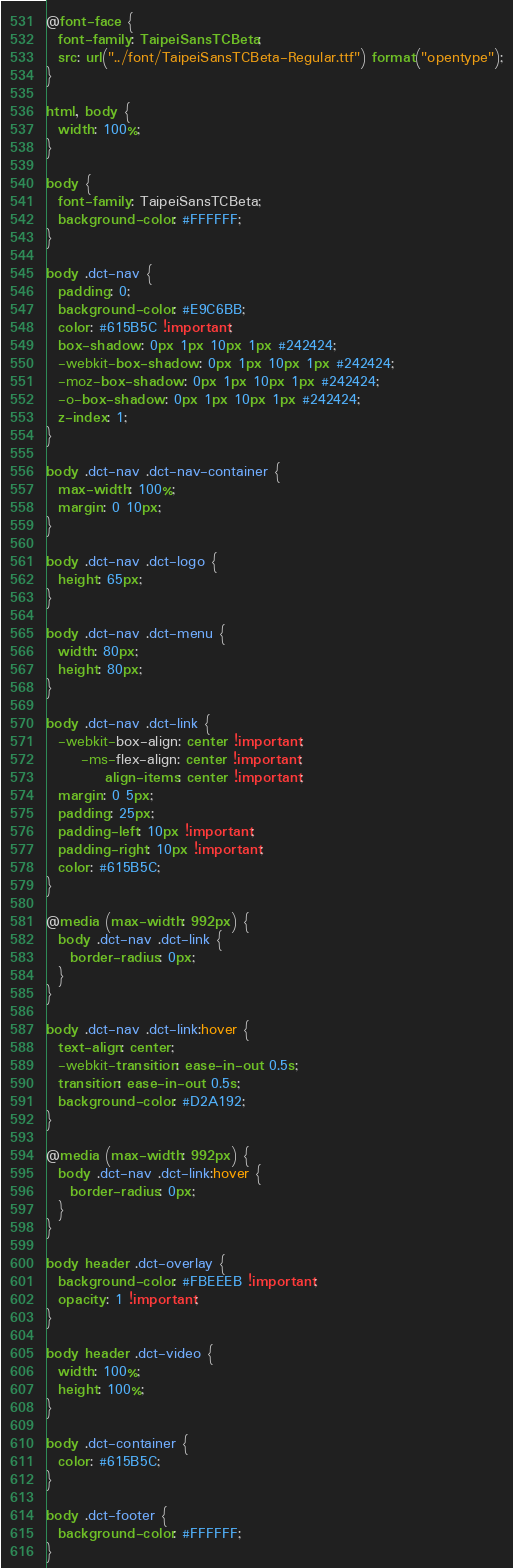<code> <loc_0><loc_0><loc_500><loc_500><_CSS_>@font-face {
  font-family: TaipeiSansTCBeta;
  src: url("../font/TaipeiSansTCBeta-Regular.ttf") format("opentype");
}

html, body {
  width: 100%;
}

body {
  font-family: TaipeiSansTCBeta;
  background-color: #FFFFFF;
}

body .dct-nav {
  padding: 0;
  background-color: #E9C6BB;
  color: #615B5C !important;
  box-shadow: 0px 1px 10px 1px #242424;
  -webkit-box-shadow: 0px 1px 10px 1px #242424;
  -moz-box-shadow: 0px 1px 10px 1px #242424;
  -o-box-shadow: 0px 1px 10px 1px #242424;
  z-index: 1;
}

body .dct-nav .dct-nav-container {
  max-width: 100%;
  margin: 0 10px;
}

body .dct-nav .dct-logo {
  height: 65px;
}

body .dct-nav .dct-menu {
  width: 80px;
  height: 80px;
}

body .dct-nav .dct-link {
  -webkit-box-align: center !important;
      -ms-flex-align: center !important;
          align-items: center !important;
  margin: 0 5px;
  padding: 25px;
  padding-left: 10px !important;
  padding-right: 10px !important;
  color: #615B5C;
}

@media (max-width: 992px) {
  body .dct-nav .dct-link {
    border-radius: 0px;
  }
}

body .dct-nav .dct-link:hover {
  text-align: center;
  -webkit-transition: ease-in-out 0.5s;
  transition: ease-in-out 0.5s;
  background-color: #D2A192;
}

@media (max-width: 992px) {
  body .dct-nav .dct-link:hover {
    border-radius: 0px;
  }
}

body header .dct-overlay {
  background-color: #FBEEEB !important;
  opacity: 1 !important;
}

body header .dct-video {
  width: 100%;
  height: 100%;
}

body .dct-container {
  color: #615B5C;
}

body .dct-footer {
  background-color: #FFFFFF;
}
</code> 